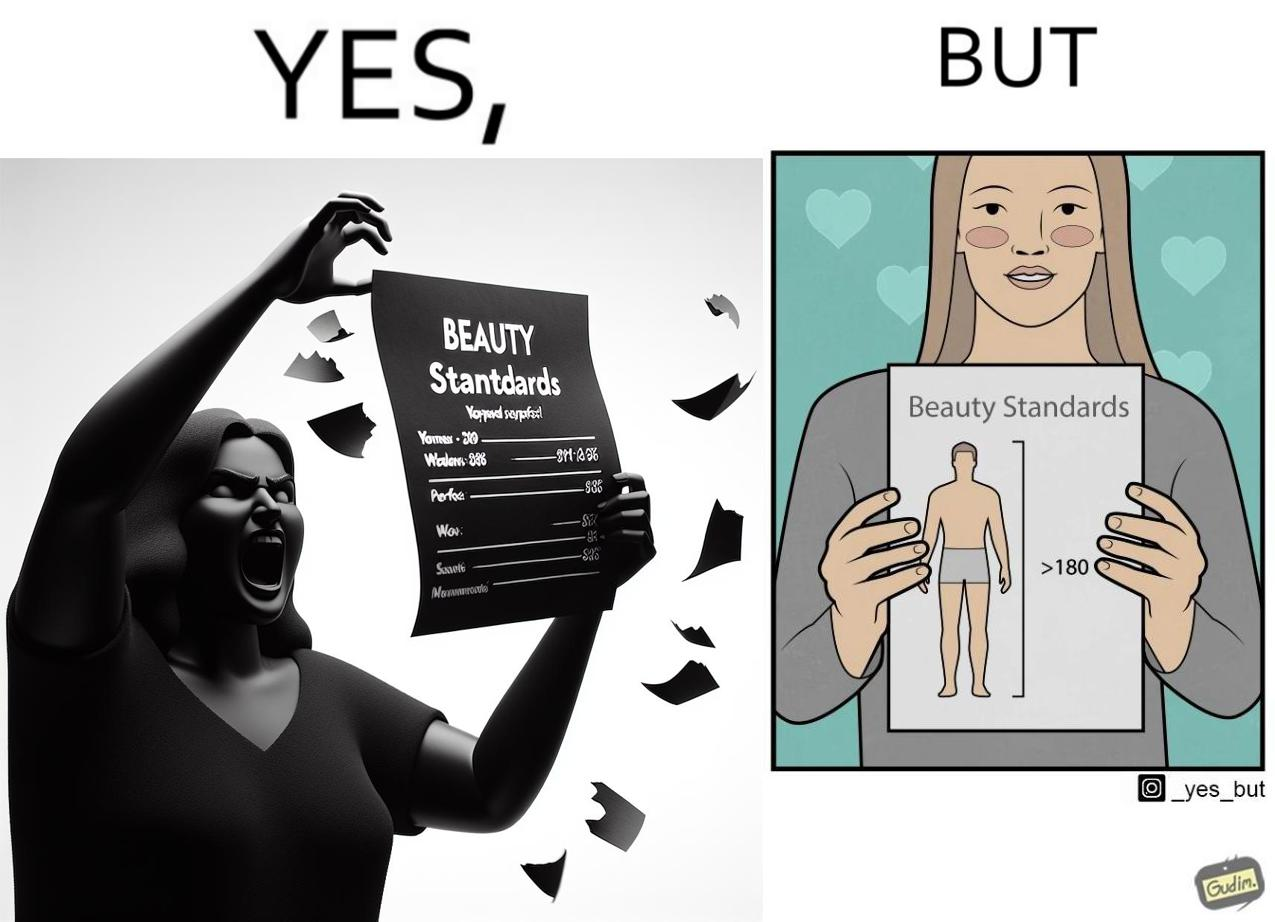What do you see in each half of this image? In the left part of the image: The image shows an angry woman tearing a piece of paper titled 'Beauty Standards' that shows the ideal measurements of various parts of a female's body to be called beautiful. In the right part of the image: The image shows a happy woman showing a piece of paper titled 'Beauty Standards' that shows that the ideal height of a male's body should be more than 180cm to be called beautiful. 